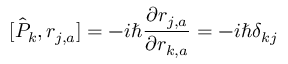<formula> <loc_0><loc_0><loc_500><loc_500>[ \hat { P } _ { k } , r _ { j , a } ] = - i \hbar { } \partial r _ { j , a } } { \partial r _ { k , a } } = - i \hbar { \delta } _ { k j }</formula> 